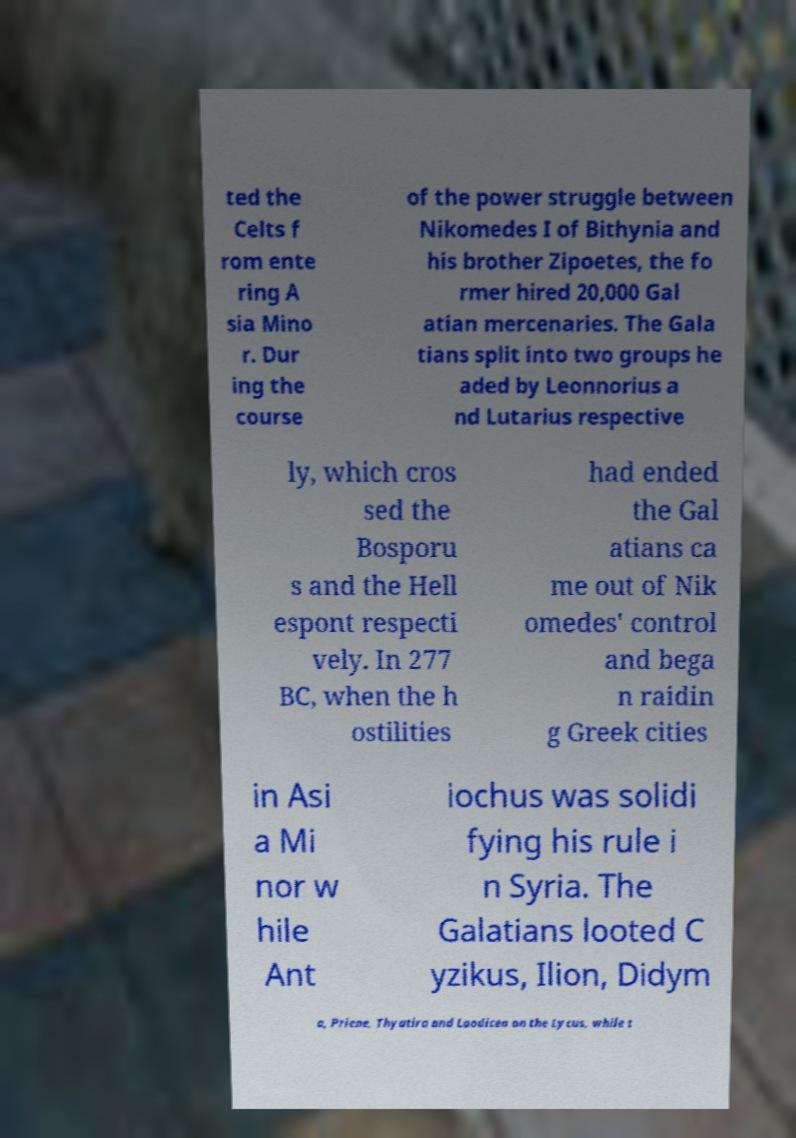Can you read and provide the text displayed in the image?This photo seems to have some interesting text. Can you extract and type it out for me? ted the Celts f rom ente ring A sia Mino r. Dur ing the course of the power struggle between Nikomedes I of Bithynia and his brother Zipoetes, the fo rmer hired 20,000 Gal atian mercenaries. The Gala tians split into two groups he aded by Leonnorius a nd Lutarius respective ly, which cros sed the Bosporu s and the Hell espont respecti vely. In 277 BC, when the h ostilities had ended the Gal atians ca me out of Nik omedes' control and bega n raidin g Greek cities in Asi a Mi nor w hile Ant iochus was solidi fying his rule i n Syria. The Galatians looted C yzikus, Ilion, Didym a, Priene, Thyatira and Laodicea on the Lycus, while t 